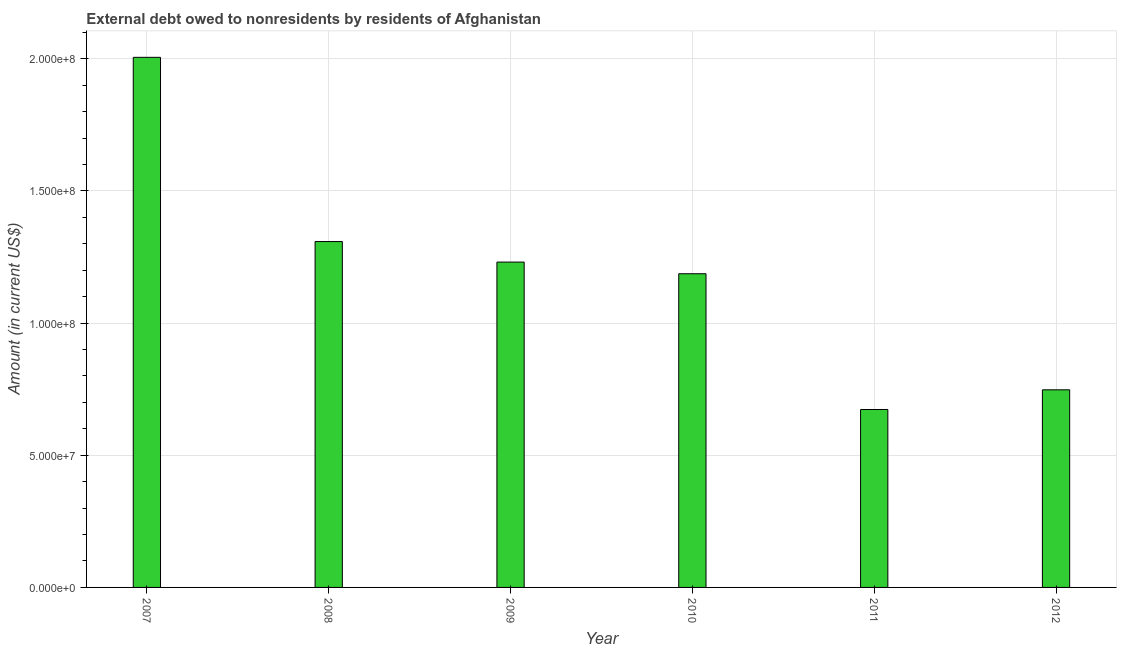Does the graph contain any zero values?
Give a very brief answer. No. Does the graph contain grids?
Ensure brevity in your answer.  Yes. What is the title of the graph?
Provide a succinct answer. External debt owed to nonresidents by residents of Afghanistan. What is the label or title of the X-axis?
Provide a short and direct response. Year. What is the label or title of the Y-axis?
Your answer should be compact. Amount (in current US$). What is the debt in 2011?
Offer a terse response. 6.73e+07. Across all years, what is the maximum debt?
Offer a terse response. 2.01e+08. Across all years, what is the minimum debt?
Your answer should be compact. 6.73e+07. In which year was the debt maximum?
Your response must be concise. 2007. In which year was the debt minimum?
Provide a short and direct response. 2011. What is the sum of the debt?
Your answer should be very brief. 7.15e+08. What is the difference between the debt in 2009 and 2010?
Your answer should be compact. 4.41e+06. What is the average debt per year?
Keep it short and to the point. 1.19e+08. What is the median debt?
Offer a terse response. 1.21e+08. In how many years, is the debt greater than 110000000 US$?
Your answer should be very brief. 4. Do a majority of the years between 2008 and 2010 (inclusive) have debt greater than 130000000 US$?
Provide a succinct answer. No. What is the ratio of the debt in 2008 to that in 2011?
Make the answer very short. 1.94. Is the difference between the debt in 2008 and 2010 greater than the difference between any two years?
Make the answer very short. No. What is the difference between the highest and the second highest debt?
Your answer should be compact. 6.97e+07. Is the sum of the debt in 2008 and 2011 greater than the maximum debt across all years?
Offer a very short reply. No. What is the difference between the highest and the lowest debt?
Give a very brief answer. 1.33e+08. How many bars are there?
Provide a short and direct response. 6. How many years are there in the graph?
Ensure brevity in your answer.  6. What is the Amount (in current US$) in 2007?
Provide a succinct answer. 2.01e+08. What is the Amount (in current US$) in 2008?
Keep it short and to the point. 1.31e+08. What is the Amount (in current US$) of 2009?
Offer a terse response. 1.23e+08. What is the Amount (in current US$) of 2010?
Offer a terse response. 1.19e+08. What is the Amount (in current US$) in 2011?
Your answer should be very brief. 6.73e+07. What is the Amount (in current US$) in 2012?
Keep it short and to the point. 7.48e+07. What is the difference between the Amount (in current US$) in 2007 and 2008?
Offer a very short reply. 6.97e+07. What is the difference between the Amount (in current US$) in 2007 and 2009?
Offer a terse response. 7.75e+07. What is the difference between the Amount (in current US$) in 2007 and 2010?
Keep it short and to the point. 8.19e+07. What is the difference between the Amount (in current US$) in 2007 and 2011?
Keep it short and to the point. 1.33e+08. What is the difference between the Amount (in current US$) in 2007 and 2012?
Keep it short and to the point. 1.26e+08. What is the difference between the Amount (in current US$) in 2008 and 2009?
Your response must be concise. 7.76e+06. What is the difference between the Amount (in current US$) in 2008 and 2010?
Keep it short and to the point. 1.22e+07. What is the difference between the Amount (in current US$) in 2008 and 2011?
Offer a very short reply. 6.35e+07. What is the difference between the Amount (in current US$) in 2008 and 2012?
Your answer should be compact. 5.61e+07. What is the difference between the Amount (in current US$) in 2009 and 2010?
Ensure brevity in your answer.  4.41e+06. What is the difference between the Amount (in current US$) in 2009 and 2011?
Your response must be concise. 5.58e+07. What is the difference between the Amount (in current US$) in 2009 and 2012?
Provide a succinct answer. 4.83e+07. What is the difference between the Amount (in current US$) in 2010 and 2011?
Your answer should be compact. 5.14e+07. What is the difference between the Amount (in current US$) in 2010 and 2012?
Your answer should be very brief. 4.39e+07. What is the difference between the Amount (in current US$) in 2011 and 2012?
Ensure brevity in your answer.  -7.45e+06. What is the ratio of the Amount (in current US$) in 2007 to that in 2008?
Your response must be concise. 1.53. What is the ratio of the Amount (in current US$) in 2007 to that in 2009?
Provide a succinct answer. 1.63. What is the ratio of the Amount (in current US$) in 2007 to that in 2010?
Offer a terse response. 1.69. What is the ratio of the Amount (in current US$) in 2007 to that in 2011?
Make the answer very short. 2.98. What is the ratio of the Amount (in current US$) in 2007 to that in 2012?
Your answer should be compact. 2.68. What is the ratio of the Amount (in current US$) in 2008 to that in 2009?
Provide a succinct answer. 1.06. What is the ratio of the Amount (in current US$) in 2008 to that in 2010?
Give a very brief answer. 1.1. What is the ratio of the Amount (in current US$) in 2008 to that in 2011?
Your answer should be very brief. 1.94. What is the ratio of the Amount (in current US$) in 2009 to that in 2010?
Make the answer very short. 1.04. What is the ratio of the Amount (in current US$) in 2009 to that in 2011?
Provide a succinct answer. 1.83. What is the ratio of the Amount (in current US$) in 2009 to that in 2012?
Your answer should be compact. 1.65. What is the ratio of the Amount (in current US$) in 2010 to that in 2011?
Give a very brief answer. 1.76. What is the ratio of the Amount (in current US$) in 2010 to that in 2012?
Your response must be concise. 1.59. What is the ratio of the Amount (in current US$) in 2011 to that in 2012?
Offer a very short reply. 0.9. 